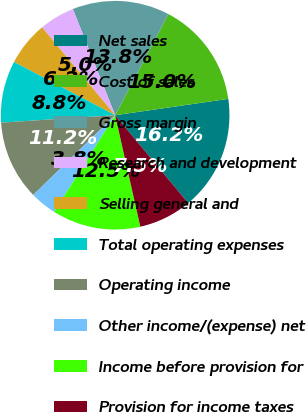Convert chart. <chart><loc_0><loc_0><loc_500><loc_500><pie_chart><fcel>Net sales<fcel>Cost of sales<fcel>Gross margin<fcel>Research and development<fcel>Selling general and<fcel>Total operating expenses<fcel>Operating income<fcel>Other income/(expense) net<fcel>Income before provision for<fcel>Provision for income taxes<nl><fcel>16.25%<fcel>15.0%<fcel>13.75%<fcel>5.0%<fcel>6.25%<fcel>8.75%<fcel>11.25%<fcel>3.75%<fcel>12.5%<fcel>7.5%<nl></chart> 